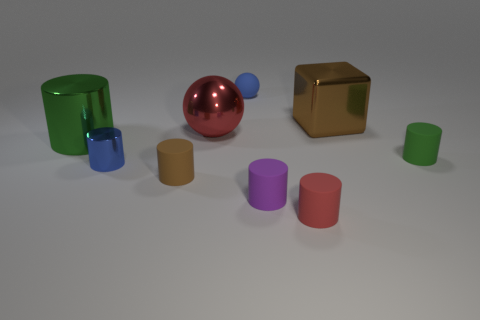What is the shape of the big green thing?
Keep it short and to the point. Cylinder. What size is the shiny cylinder that is behind the tiny blue metal cylinder that is left of the tiny matte thing in front of the small purple object?
Make the answer very short. Large. What number of other objects are there of the same shape as the blue rubber thing?
Ensure brevity in your answer.  1. There is a large metal thing that is left of the big ball; does it have the same shape as the brown thing that is in front of the brown cube?
Make the answer very short. Yes. What number of balls are either brown metal things or tiny green rubber objects?
Make the answer very short. 0. What material is the green cylinder that is on the left side of the blue object on the left side of the matte ball that is behind the big red sphere?
Provide a short and direct response. Metal. How many other things are the same size as the brown rubber thing?
Offer a very short reply. 5. There is a matte ball that is the same color as the tiny metal cylinder; what size is it?
Ensure brevity in your answer.  Small. Are there more matte things behind the brown cylinder than brown shiny things?
Provide a short and direct response. Yes. Are there any tiny matte objects that have the same color as the shiny block?
Your answer should be compact. Yes. 